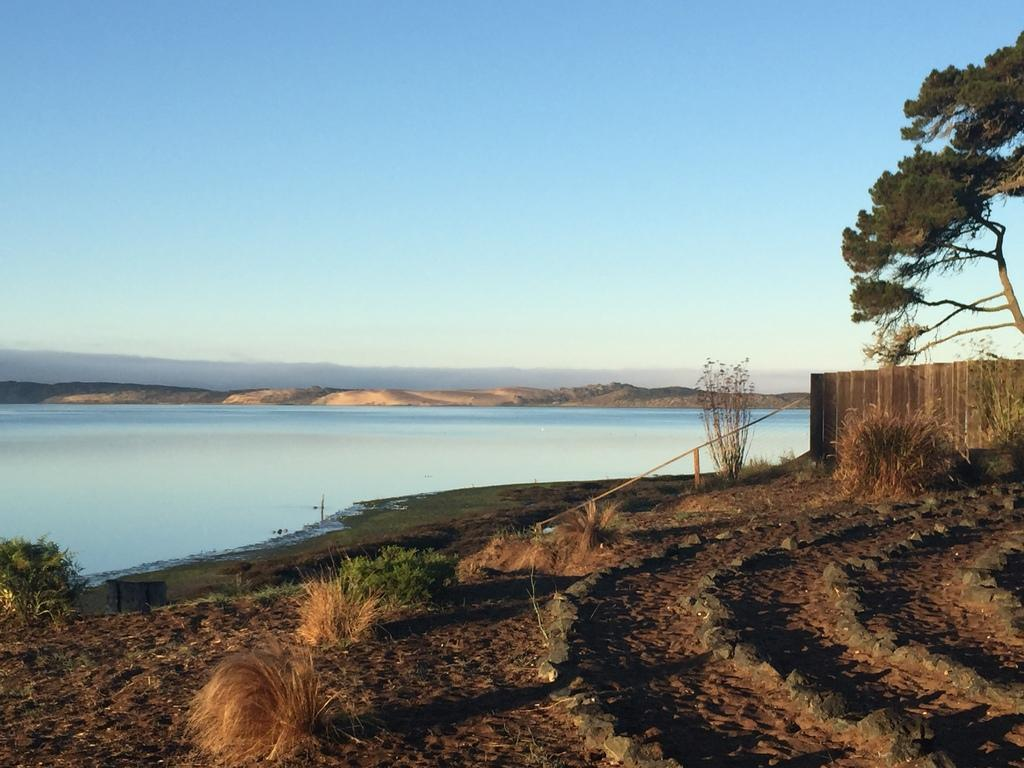What is arranged on the ground in the image? There are stones arranged on the ground. What type of vegetation is present on the ground? There is white grass and plants on the ground. What can be seen in the background of the image? There is a wall, trees, water, mountains, and clouds in the sky in the background. What language is spoken by the tax accountant in the image? There is no tax accountant or language spoken in the image; it features stones, white grass, plants, a wall, trees, water, mountains, and clouds. 